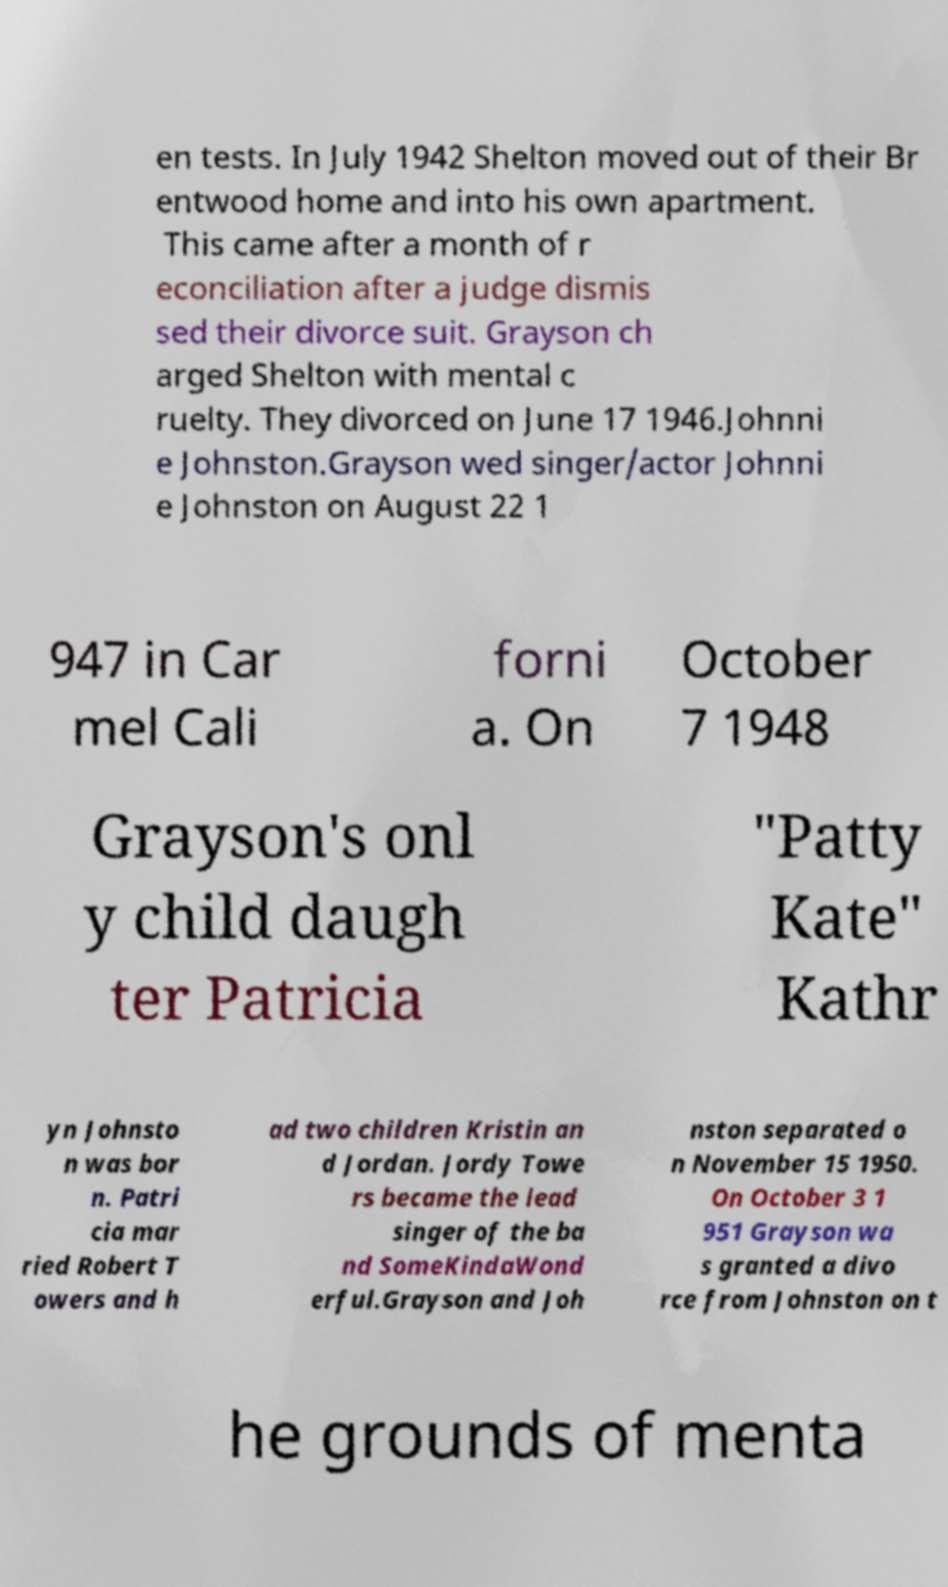Please read and relay the text visible in this image. What does it say? en tests. In July 1942 Shelton moved out of their Br entwood home and into his own apartment. This came after a month of r econciliation after a judge dismis sed their divorce suit. Grayson ch arged Shelton with mental c ruelty. They divorced on June 17 1946.Johnni e Johnston.Grayson wed singer/actor Johnni e Johnston on August 22 1 947 in Car mel Cali forni a. On October 7 1948 Grayson's onl y child daugh ter Patricia "Patty Kate" Kathr yn Johnsto n was bor n. Patri cia mar ried Robert T owers and h ad two children Kristin an d Jordan. Jordy Towe rs became the lead singer of the ba nd SomeKindaWond erful.Grayson and Joh nston separated o n November 15 1950. On October 3 1 951 Grayson wa s granted a divo rce from Johnston on t he grounds of menta 